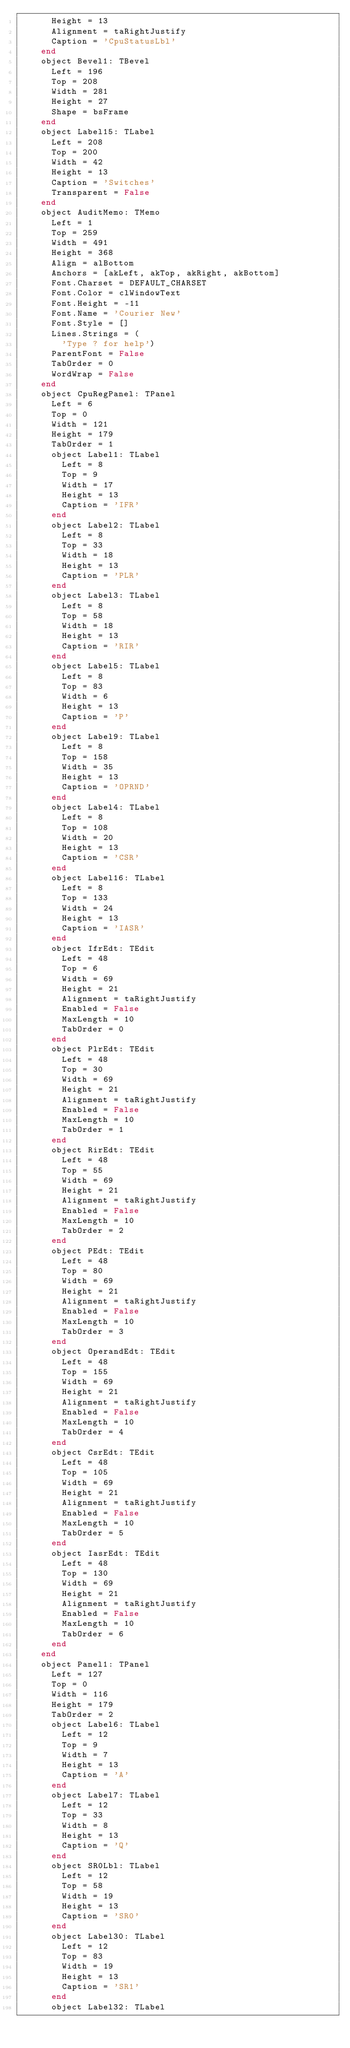<code> <loc_0><loc_0><loc_500><loc_500><_Pascal_>      Height = 13
      Alignment = taRightJustify
      Caption = 'CpuStatusLbl'
    end
    object Bevel1: TBevel
      Left = 196
      Top = 208
      Width = 281
      Height = 27
      Shape = bsFrame
    end
    object Label15: TLabel
      Left = 208
      Top = 200
      Width = 42
      Height = 13
      Caption = 'Switches'
      Transparent = False
    end
    object AuditMemo: TMemo
      Left = 1
      Top = 259
      Width = 491
      Height = 368
      Align = alBottom
      Anchors = [akLeft, akTop, akRight, akBottom]
      Font.Charset = DEFAULT_CHARSET
      Font.Color = clWindowText
      Font.Height = -11
      Font.Name = 'Courier New'
      Font.Style = []
      Lines.Strings = (
        'Type ? for help')
      ParentFont = False
      TabOrder = 0
      WordWrap = False
    end
    object CpuRegPanel: TPanel
      Left = 6
      Top = 0
      Width = 121
      Height = 179
      TabOrder = 1
      object Label1: TLabel
        Left = 8
        Top = 9
        Width = 17
        Height = 13
        Caption = 'IFR'
      end
      object Label2: TLabel
        Left = 8
        Top = 33
        Width = 18
        Height = 13
        Caption = 'PLR'
      end
      object Label3: TLabel
        Left = 8
        Top = 58
        Width = 18
        Height = 13
        Caption = 'RIR'
      end
      object Label5: TLabel
        Left = 8
        Top = 83
        Width = 6
        Height = 13
        Caption = 'P'
      end
      object Label9: TLabel
        Left = 8
        Top = 158
        Width = 35
        Height = 13
        Caption = 'OPRND'
      end
      object Label4: TLabel
        Left = 8
        Top = 108
        Width = 20
        Height = 13
        Caption = 'CSR'
      end
      object Label16: TLabel
        Left = 8
        Top = 133
        Width = 24
        Height = 13
        Caption = 'IASR'
      end
      object IfrEdt: TEdit
        Left = 48
        Top = 6
        Width = 69
        Height = 21
        Alignment = taRightJustify
        Enabled = False
        MaxLength = 10
        TabOrder = 0
      end
      object PlrEdt: TEdit
        Left = 48
        Top = 30
        Width = 69
        Height = 21
        Alignment = taRightJustify
        Enabled = False
        MaxLength = 10
        TabOrder = 1
      end
      object RirEdt: TEdit
        Left = 48
        Top = 55
        Width = 69
        Height = 21
        Alignment = taRightJustify
        Enabled = False
        MaxLength = 10
        TabOrder = 2
      end
      object PEdt: TEdit
        Left = 48
        Top = 80
        Width = 69
        Height = 21
        Alignment = taRightJustify
        Enabled = False
        MaxLength = 10
        TabOrder = 3
      end
      object OperandEdt: TEdit
        Left = 48
        Top = 155
        Width = 69
        Height = 21
        Alignment = taRightJustify
        Enabled = False
        MaxLength = 10
        TabOrder = 4
      end
      object CsrEdt: TEdit
        Left = 48
        Top = 105
        Width = 69
        Height = 21
        Alignment = taRightJustify
        Enabled = False
        MaxLength = 10
        TabOrder = 5
      end
      object IasrEdt: TEdit
        Left = 48
        Top = 130
        Width = 69
        Height = 21
        Alignment = taRightJustify
        Enabled = False
        MaxLength = 10
        TabOrder = 6
      end
    end
    object Panel1: TPanel
      Left = 127
      Top = 0
      Width = 116
      Height = 179
      TabOrder = 2
      object Label6: TLabel
        Left = 12
        Top = 9
        Width = 7
        Height = 13
        Caption = 'A'
      end
      object Label7: TLabel
        Left = 12
        Top = 33
        Width = 8
        Height = 13
        Caption = 'Q'
      end
      object SR0Lbl: TLabel
        Left = 12
        Top = 58
        Width = 19
        Height = 13
        Caption = 'SR0'
      end
      object Label30: TLabel
        Left = 12
        Top = 83
        Width = 19
        Height = 13
        Caption = 'SR1'
      end
      object Label32: TLabel</code> 